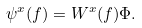<formula> <loc_0><loc_0><loc_500><loc_500>\psi ^ { x } ( f ) = W ^ { x } ( f ) \Phi .</formula> 